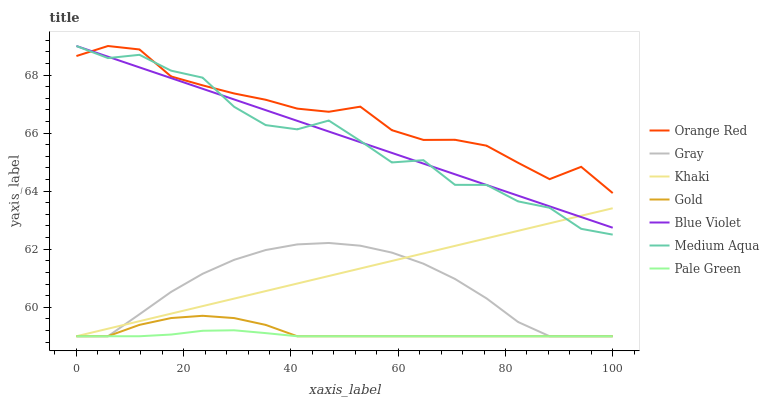Does Pale Green have the minimum area under the curve?
Answer yes or no. Yes. Does Orange Red have the maximum area under the curve?
Answer yes or no. Yes. Does Khaki have the minimum area under the curve?
Answer yes or no. No. Does Khaki have the maximum area under the curve?
Answer yes or no. No. Is Khaki the smoothest?
Answer yes or no. Yes. Is Medium Aqua the roughest?
Answer yes or no. Yes. Is Gold the smoothest?
Answer yes or no. No. Is Gold the roughest?
Answer yes or no. No. Does Medium Aqua have the lowest value?
Answer yes or no. No. Does Blue Violet have the highest value?
Answer yes or no. Yes. Does Khaki have the highest value?
Answer yes or no. No. Is Gold less than Blue Violet?
Answer yes or no. Yes. Is Orange Red greater than Pale Green?
Answer yes or no. Yes. Does Blue Violet intersect Orange Red?
Answer yes or no. Yes. Is Blue Violet less than Orange Red?
Answer yes or no. No. Is Blue Violet greater than Orange Red?
Answer yes or no. No. Does Gold intersect Blue Violet?
Answer yes or no. No. 